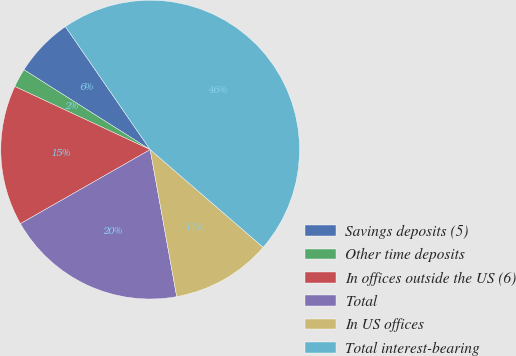Convert chart to OTSL. <chart><loc_0><loc_0><loc_500><loc_500><pie_chart><fcel>Savings deposits (5)<fcel>Other time deposits<fcel>In offices outside the US (6)<fcel>Total<fcel>In US offices<fcel>Total interest-bearing<nl><fcel>6.42%<fcel>2.03%<fcel>15.2%<fcel>19.59%<fcel>10.81%<fcel>45.94%<nl></chart> 